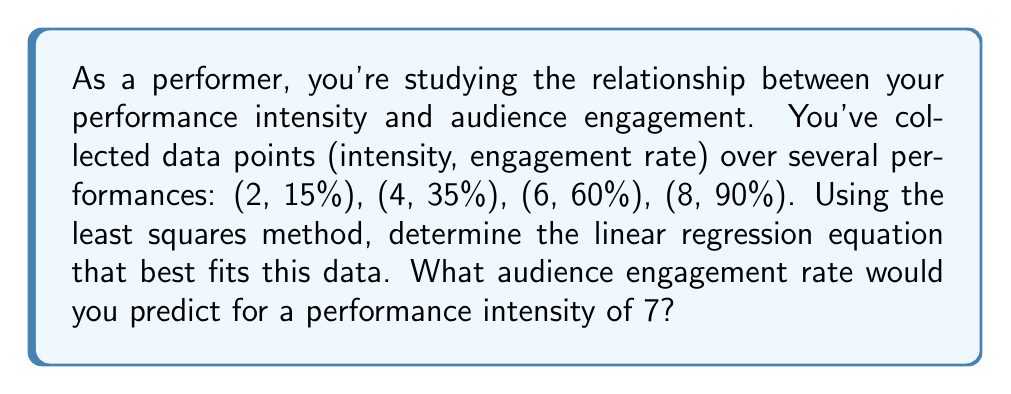Give your solution to this math problem. Let's solve this step-by-step using the least squares method:

1) We have n = 4 data points: (2, 15), (4, 35), (6, 60), (8, 90)

2) We need to find the coefficients a and b in the equation y = ax + b

3) The formulas for a and b are:

   $$a = \frac{n\sum xy - \sum x \sum y}{n\sum x^2 - (\sum x)^2}$$

   $$b = \frac{\sum y \sum x^2 - \sum x \sum xy}{n\sum x^2 - (\sum x)^2}$$

4) Let's calculate the sums we need:

   $\sum x = 2 + 4 + 6 + 8 = 20$
   $\sum y = 15 + 35 + 60 + 90 = 200$
   $\sum xy = 2(15) + 4(35) + 6(60) + 8(90) = 1130$
   $\sum x^2 = 2^2 + 4^2 + 6^2 + 8^2 = 120$

5) Now we can plug these into our formulas:

   $$a = \frac{4(1130) - 20(200)}{4(120) - 20^2} = \frac{4520 - 4000}{480 - 400} = \frac{520}{80} = 6.5$$

   $$b = \frac{200(120) - 20(1130)}{4(120) - 20^2} = \frac{24000 - 22600}{480 - 400} = \frac{1400}{80} = 17.5$$

6) Our linear regression equation is:

   $y = 6.5x - 17.5$

7) To predict the engagement rate for an intensity of 7:

   $y = 6.5(7) - 17.5 = 45.5 - 17.5 = 28$

Therefore, for a performance intensity of 7, we predict an audience engagement rate of 28%.
Answer: 28% 